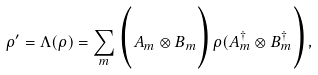<formula> <loc_0><loc_0><loc_500><loc_500>\rho ^ { \prime } = \Lambda ( \rho ) = \sum _ { m } \Big ( A _ { m } \otimes B _ { m } \Big ) \rho ( A _ { m } ^ { \dagger } \otimes B _ { m } ^ { \dagger } \Big ) ,</formula> 